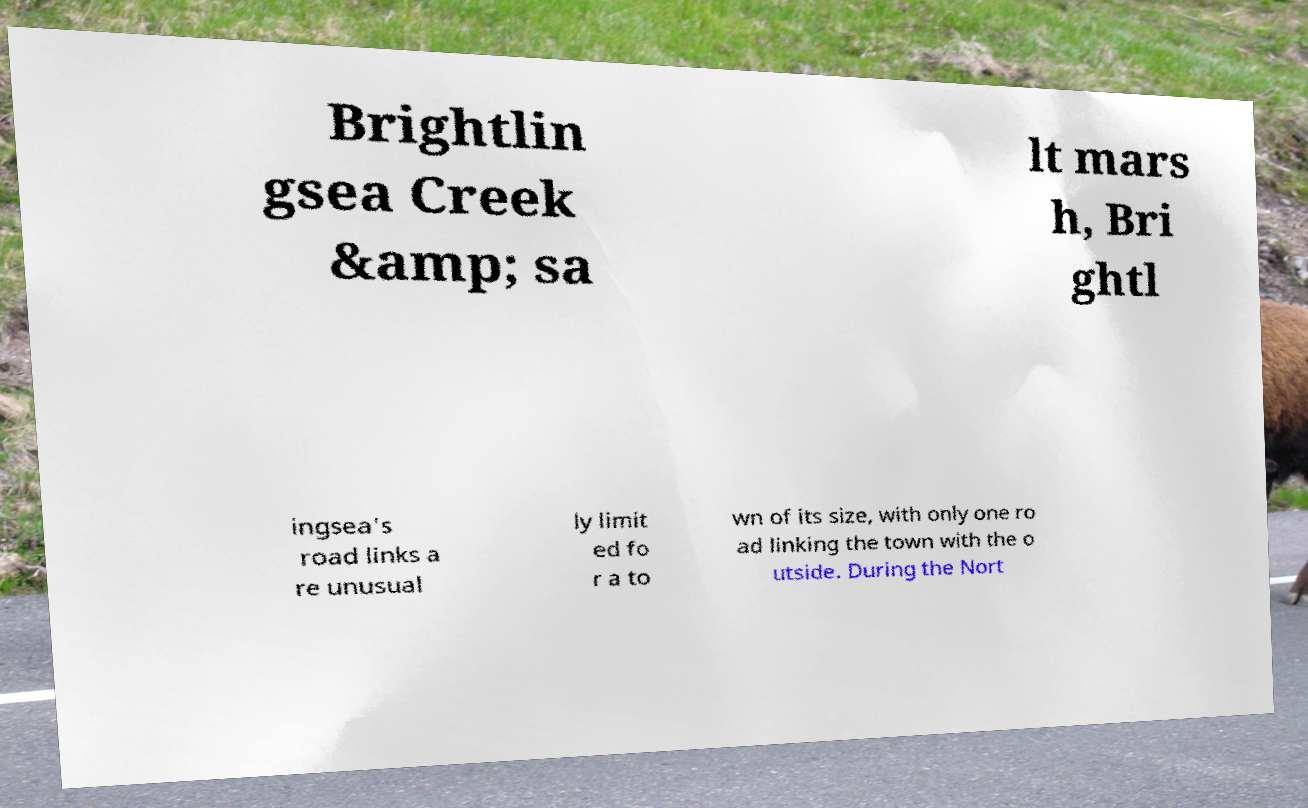Can you accurately transcribe the text from the provided image for me? Brightlin gsea Creek &amp; sa lt mars h, Bri ghtl ingsea's road links a re unusual ly limit ed fo r a to wn of its size, with only one ro ad linking the town with the o utside. During the Nort 